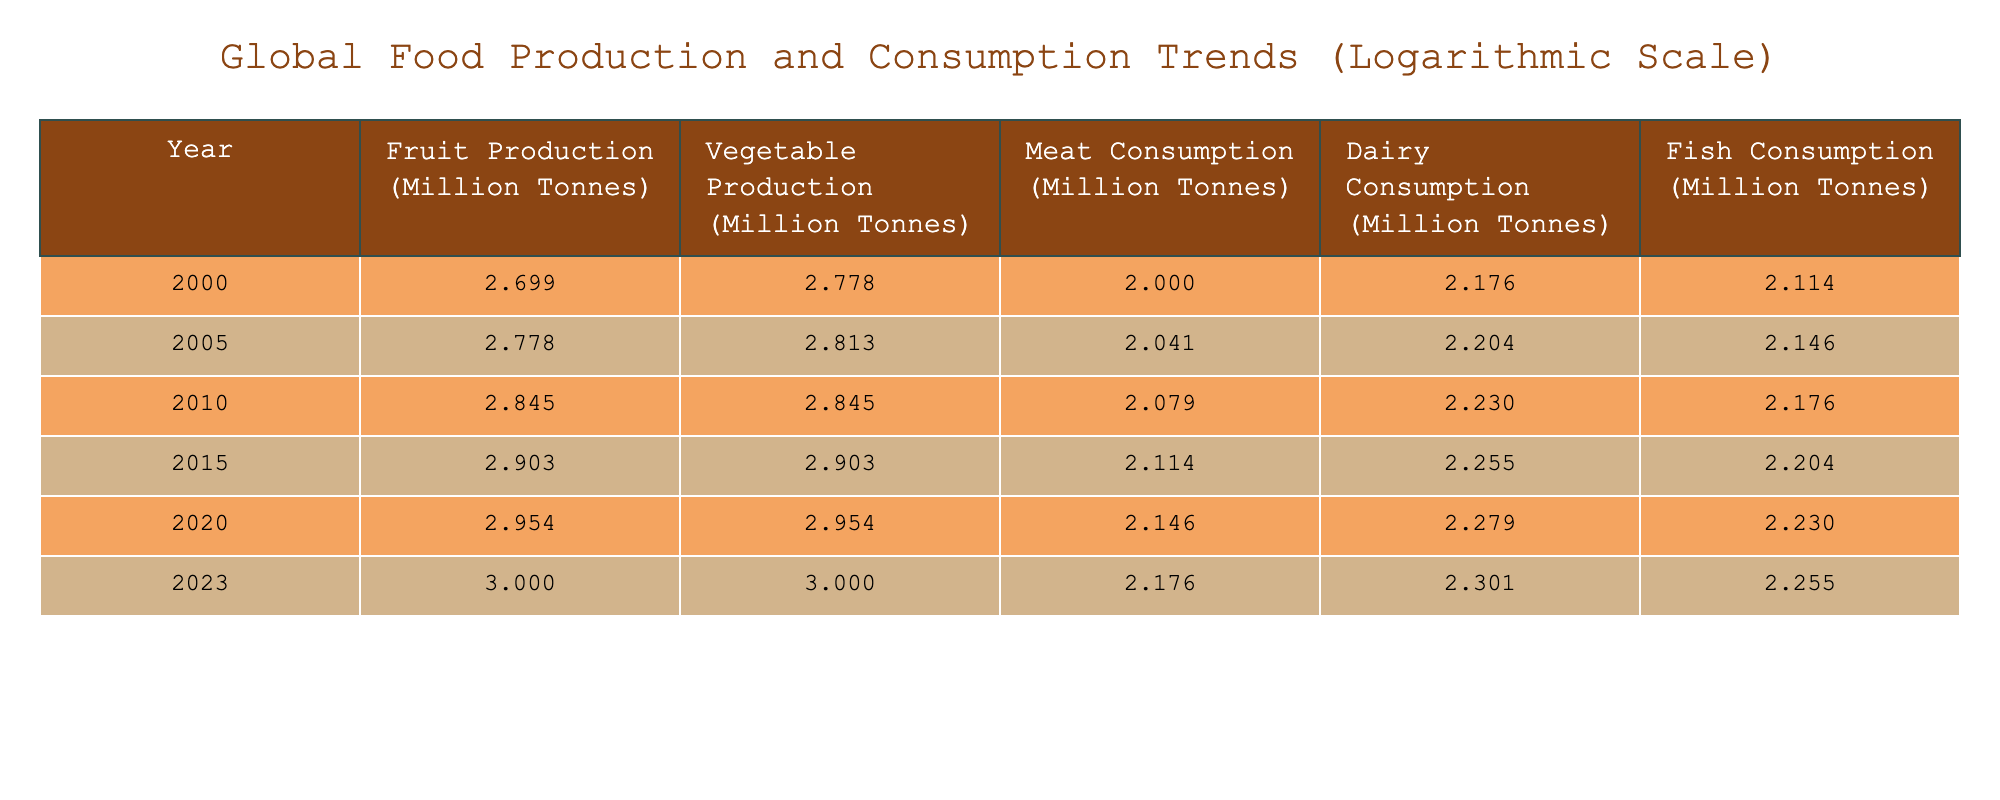What was the meat consumption in 2020? Referring to the table, under the 'Meat Consumption' column for the year 2020, the value is directly listed as 140 million tonnes.
Answer: 140 million tonnes What was the difference in fruit production from 2000 to 2023? To find the difference, we subtract the fruit production in 2000 (500 million tonnes) from that in 2023 (1000 million tonnes): 1000 - 500 = 500 million tonnes.
Answer: 500 million tonnes Was vegetable production in 2010 higher or lower than that in 2005? By comparing the values from the table, vegetable production in 2010 was 700 million tonnes and in 2005 it was 650 million tonnes. Since 700 > 650, it was higher.
Answer: Higher What is the average dairy consumption from 2000 to 2023? We sum the dairy consumption values for each year: 150 + 160 + 170 + 180 + 190 + 200 = 1150 million tonnes. Then we divide by the number of years (6): 1150/6 = approximately 191.67 million tonnes.
Answer: Approximately 191.67 million tonnes Which year had the highest fish consumption? By looking through the values in the 'Fish Consumption' column, we find the maximum value. The highest value is 180 million tonnes in the year 2023.
Answer: 2023 What was the total production of fruits and vegetables in 2015? To find the total, we sum the fruit production (800 million tonnes) and vegetable production (800 million tonnes) for 2015: 800 + 800 = 1600 million tonnes.
Answer: 1600 million tonnes Did dairy consumption increase every five years from 2000 to 2023? Checking the table, we see that dairy consumption values for each five-year increment are: 150, 160, 170, 180, 190, 200. Each subsequent value is greater than the previous one, confirming it indeed increased every five years.
Answer: Yes What was the percentage increase in fish consumption from 2000 to 2020? First, we find the difference in fish consumption between 2000 (130 million tonnes) and 2020 (170 million tonnes): 170 - 130 = 40 million tonnes. The percentage increase is then (40/130) * 100%. This results in approximately 30.77%.
Answer: Approximately 30.77% 